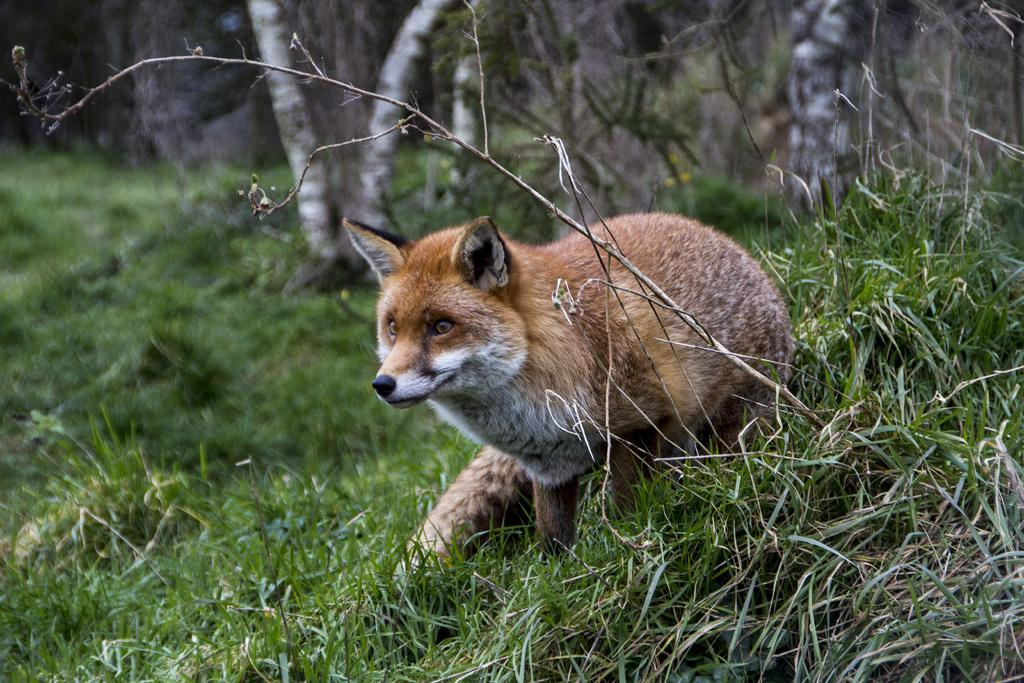What animal is present in the image? There is a fox in the image. What colors can be seen on the fox? The fox is white and cream in color. What type of vegetation is visible in the image? There is green grass in the image. How would you describe the background of the image? The background is blurred. Can you see a bottle of wine in the image? There is no bottle of wine present in the image. 